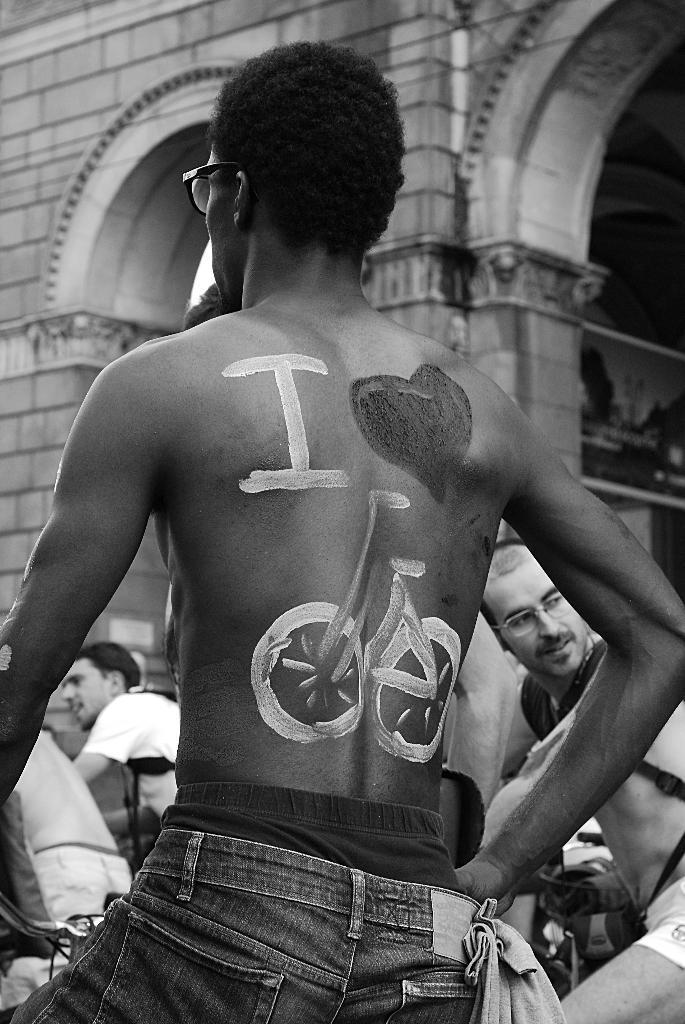Could you give a brief overview of what you see in this image? In the foreground of the picture I can see a man without shirt and there is a painting of bicycle on his body. In the background, I can see three persons. I can see the arch design construction at the top of the picture. 